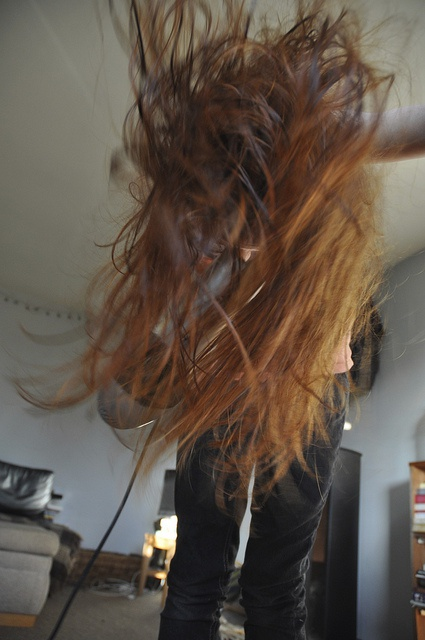Describe the objects in this image and their specific colors. I can see people in gray, black, and maroon tones, couch in gray, black, and maroon tones, and hair drier in gray, maroon, and black tones in this image. 